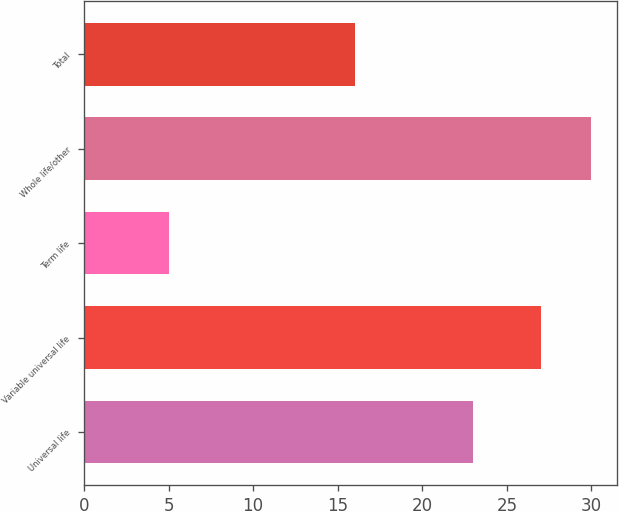Convert chart. <chart><loc_0><loc_0><loc_500><loc_500><bar_chart><fcel>Universal life<fcel>Variable universal life<fcel>Term life<fcel>Whole life/other<fcel>Total<nl><fcel>23<fcel>27<fcel>5<fcel>30<fcel>16<nl></chart> 